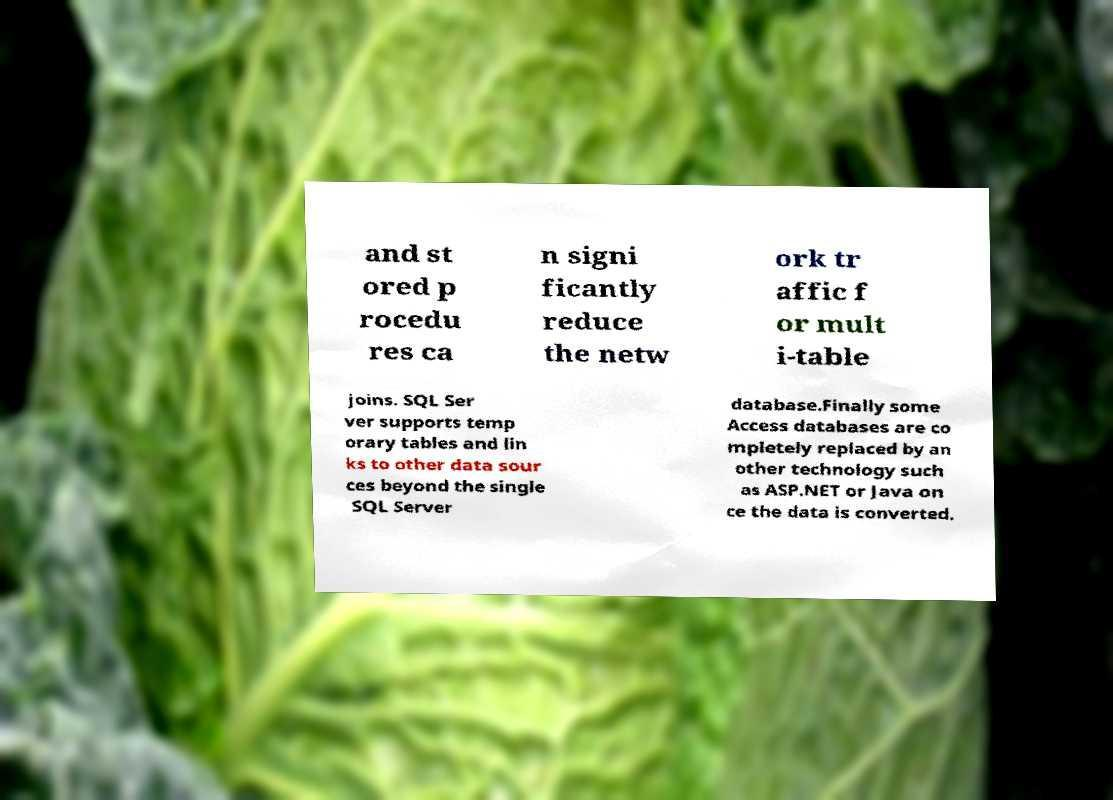I need the written content from this picture converted into text. Can you do that? and st ored p rocedu res ca n signi ficantly reduce the netw ork tr affic f or mult i-table joins. SQL Ser ver supports temp orary tables and lin ks to other data sour ces beyond the single SQL Server database.Finally some Access databases are co mpletely replaced by an other technology such as ASP.NET or Java on ce the data is converted. 